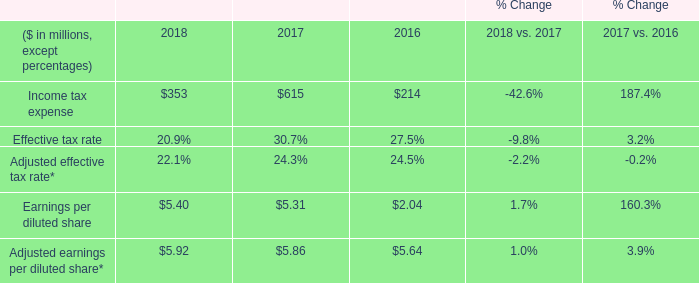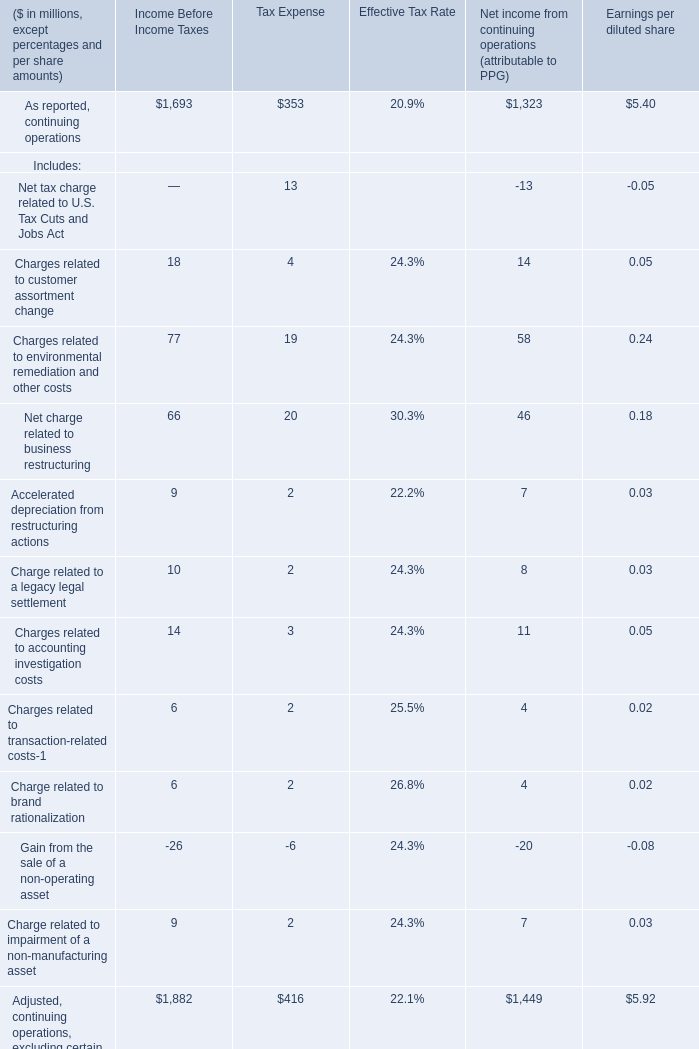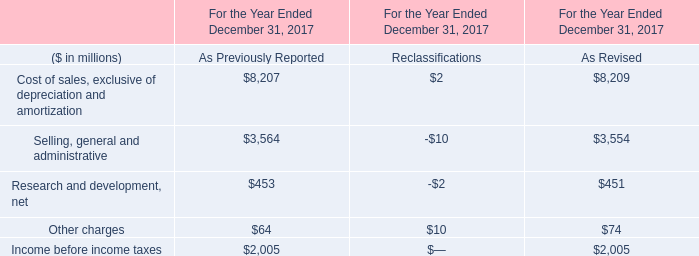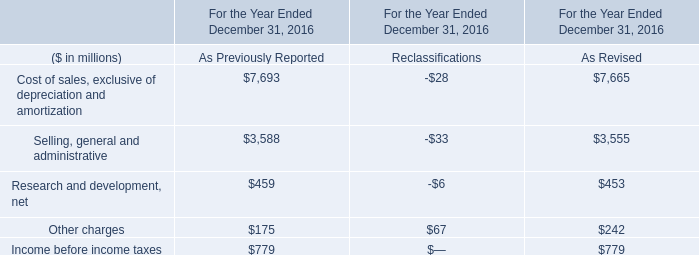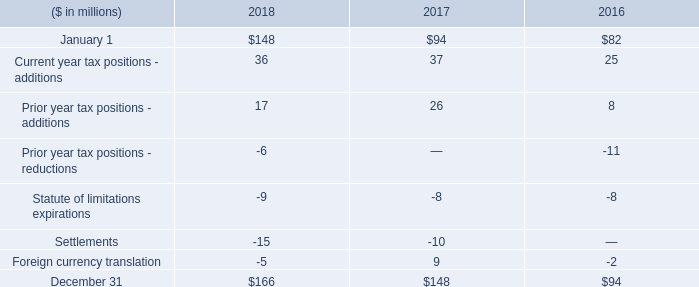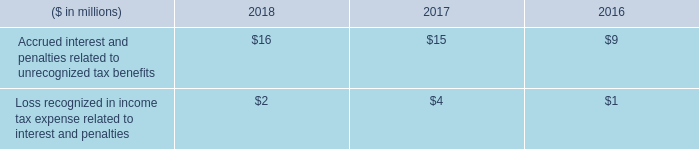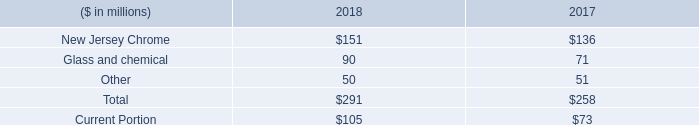what was the percentage increase in the new jersey chrome environmental reserve in 2018? 
Computations: ((151 - 136) / 136)
Answer: 0.11029. 